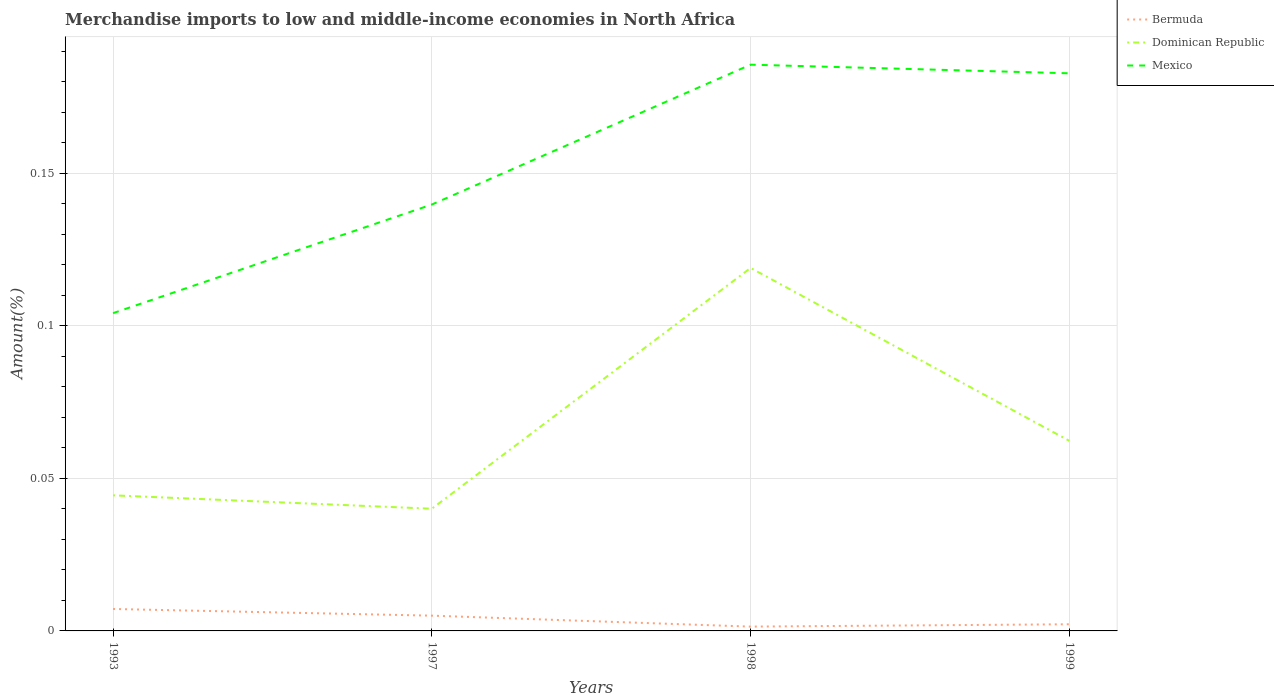How many different coloured lines are there?
Keep it short and to the point. 3. Does the line corresponding to Mexico intersect with the line corresponding to Bermuda?
Offer a very short reply. No. Across all years, what is the maximum percentage of amount earned from merchandise imports in Dominican Republic?
Ensure brevity in your answer.  0.04. What is the total percentage of amount earned from merchandise imports in Mexico in the graph?
Ensure brevity in your answer.  -0.08. What is the difference between the highest and the second highest percentage of amount earned from merchandise imports in Dominican Republic?
Your answer should be compact. 0.08. What is the difference between the highest and the lowest percentage of amount earned from merchandise imports in Bermuda?
Make the answer very short. 2. Is the percentage of amount earned from merchandise imports in Mexico strictly greater than the percentage of amount earned from merchandise imports in Bermuda over the years?
Offer a very short reply. No. How many years are there in the graph?
Provide a short and direct response. 4. Does the graph contain any zero values?
Provide a succinct answer. No. Where does the legend appear in the graph?
Provide a succinct answer. Top right. What is the title of the graph?
Ensure brevity in your answer.  Merchandise imports to low and middle-income economies in North Africa. Does "Turkmenistan" appear as one of the legend labels in the graph?
Offer a terse response. No. What is the label or title of the X-axis?
Give a very brief answer. Years. What is the label or title of the Y-axis?
Provide a short and direct response. Amount(%). What is the Amount(%) of Bermuda in 1993?
Your answer should be very brief. 0.01. What is the Amount(%) of Dominican Republic in 1993?
Your answer should be compact. 0.04. What is the Amount(%) of Mexico in 1993?
Ensure brevity in your answer.  0.1. What is the Amount(%) in Bermuda in 1997?
Your response must be concise. 0.01. What is the Amount(%) in Dominican Republic in 1997?
Offer a very short reply. 0.04. What is the Amount(%) in Mexico in 1997?
Ensure brevity in your answer.  0.14. What is the Amount(%) of Bermuda in 1998?
Your response must be concise. 0. What is the Amount(%) in Dominican Republic in 1998?
Offer a terse response. 0.12. What is the Amount(%) of Mexico in 1998?
Keep it short and to the point. 0.19. What is the Amount(%) of Bermuda in 1999?
Your response must be concise. 0. What is the Amount(%) of Dominican Republic in 1999?
Offer a very short reply. 0.06. What is the Amount(%) in Mexico in 1999?
Your answer should be very brief. 0.18. Across all years, what is the maximum Amount(%) of Bermuda?
Make the answer very short. 0.01. Across all years, what is the maximum Amount(%) of Dominican Republic?
Your response must be concise. 0.12. Across all years, what is the maximum Amount(%) in Mexico?
Keep it short and to the point. 0.19. Across all years, what is the minimum Amount(%) of Bermuda?
Keep it short and to the point. 0. Across all years, what is the minimum Amount(%) in Dominican Republic?
Provide a short and direct response. 0.04. Across all years, what is the minimum Amount(%) of Mexico?
Make the answer very short. 0.1. What is the total Amount(%) of Bermuda in the graph?
Offer a very short reply. 0.02. What is the total Amount(%) in Dominican Republic in the graph?
Give a very brief answer. 0.27. What is the total Amount(%) in Mexico in the graph?
Keep it short and to the point. 0.61. What is the difference between the Amount(%) of Bermuda in 1993 and that in 1997?
Your answer should be very brief. 0. What is the difference between the Amount(%) in Dominican Republic in 1993 and that in 1997?
Your answer should be compact. 0. What is the difference between the Amount(%) of Mexico in 1993 and that in 1997?
Keep it short and to the point. -0.04. What is the difference between the Amount(%) in Bermuda in 1993 and that in 1998?
Offer a very short reply. 0.01. What is the difference between the Amount(%) of Dominican Republic in 1993 and that in 1998?
Ensure brevity in your answer.  -0.07. What is the difference between the Amount(%) in Mexico in 1993 and that in 1998?
Give a very brief answer. -0.08. What is the difference between the Amount(%) of Bermuda in 1993 and that in 1999?
Make the answer very short. 0.01. What is the difference between the Amount(%) of Dominican Republic in 1993 and that in 1999?
Ensure brevity in your answer.  -0.02. What is the difference between the Amount(%) of Mexico in 1993 and that in 1999?
Your answer should be very brief. -0.08. What is the difference between the Amount(%) in Bermuda in 1997 and that in 1998?
Offer a very short reply. 0. What is the difference between the Amount(%) in Dominican Republic in 1997 and that in 1998?
Offer a very short reply. -0.08. What is the difference between the Amount(%) of Mexico in 1997 and that in 1998?
Your answer should be very brief. -0.05. What is the difference between the Amount(%) of Bermuda in 1997 and that in 1999?
Ensure brevity in your answer.  0. What is the difference between the Amount(%) in Dominican Republic in 1997 and that in 1999?
Offer a terse response. -0.02. What is the difference between the Amount(%) of Mexico in 1997 and that in 1999?
Offer a terse response. -0.04. What is the difference between the Amount(%) of Bermuda in 1998 and that in 1999?
Your response must be concise. -0. What is the difference between the Amount(%) in Dominican Republic in 1998 and that in 1999?
Provide a succinct answer. 0.06. What is the difference between the Amount(%) in Mexico in 1998 and that in 1999?
Your answer should be very brief. 0. What is the difference between the Amount(%) in Bermuda in 1993 and the Amount(%) in Dominican Republic in 1997?
Keep it short and to the point. -0.03. What is the difference between the Amount(%) of Bermuda in 1993 and the Amount(%) of Mexico in 1997?
Make the answer very short. -0.13. What is the difference between the Amount(%) in Dominican Republic in 1993 and the Amount(%) in Mexico in 1997?
Ensure brevity in your answer.  -0.1. What is the difference between the Amount(%) of Bermuda in 1993 and the Amount(%) of Dominican Republic in 1998?
Provide a short and direct response. -0.11. What is the difference between the Amount(%) of Bermuda in 1993 and the Amount(%) of Mexico in 1998?
Your response must be concise. -0.18. What is the difference between the Amount(%) in Dominican Republic in 1993 and the Amount(%) in Mexico in 1998?
Make the answer very short. -0.14. What is the difference between the Amount(%) in Bermuda in 1993 and the Amount(%) in Dominican Republic in 1999?
Provide a succinct answer. -0.06. What is the difference between the Amount(%) of Bermuda in 1993 and the Amount(%) of Mexico in 1999?
Your answer should be compact. -0.18. What is the difference between the Amount(%) of Dominican Republic in 1993 and the Amount(%) of Mexico in 1999?
Offer a very short reply. -0.14. What is the difference between the Amount(%) in Bermuda in 1997 and the Amount(%) in Dominican Republic in 1998?
Make the answer very short. -0.11. What is the difference between the Amount(%) of Bermuda in 1997 and the Amount(%) of Mexico in 1998?
Ensure brevity in your answer.  -0.18. What is the difference between the Amount(%) of Dominican Republic in 1997 and the Amount(%) of Mexico in 1998?
Your answer should be compact. -0.15. What is the difference between the Amount(%) in Bermuda in 1997 and the Amount(%) in Dominican Republic in 1999?
Provide a succinct answer. -0.06. What is the difference between the Amount(%) in Bermuda in 1997 and the Amount(%) in Mexico in 1999?
Ensure brevity in your answer.  -0.18. What is the difference between the Amount(%) in Dominican Republic in 1997 and the Amount(%) in Mexico in 1999?
Your answer should be very brief. -0.14. What is the difference between the Amount(%) of Bermuda in 1998 and the Amount(%) of Dominican Republic in 1999?
Your response must be concise. -0.06. What is the difference between the Amount(%) in Bermuda in 1998 and the Amount(%) in Mexico in 1999?
Provide a short and direct response. -0.18. What is the difference between the Amount(%) in Dominican Republic in 1998 and the Amount(%) in Mexico in 1999?
Offer a very short reply. -0.06. What is the average Amount(%) in Bermuda per year?
Make the answer very short. 0. What is the average Amount(%) in Dominican Republic per year?
Your answer should be very brief. 0.07. What is the average Amount(%) in Mexico per year?
Your answer should be compact. 0.15. In the year 1993, what is the difference between the Amount(%) in Bermuda and Amount(%) in Dominican Republic?
Your answer should be very brief. -0.04. In the year 1993, what is the difference between the Amount(%) of Bermuda and Amount(%) of Mexico?
Your answer should be compact. -0.1. In the year 1993, what is the difference between the Amount(%) in Dominican Republic and Amount(%) in Mexico?
Offer a terse response. -0.06. In the year 1997, what is the difference between the Amount(%) of Bermuda and Amount(%) of Dominican Republic?
Your answer should be very brief. -0.04. In the year 1997, what is the difference between the Amount(%) of Bermuda and Amount(%) of Mexico?
Your answer should be very brief. -0.13. In the year 1997, what is the difference between the Amount(%) in Dominican Republic and Amount(%) in Mexico?
Keep it short and to the point. -0.1. In the year 1998, what is the difference between the Amount(%) of Bermuda and Amount(%) of Dominican Republic?
Keep it short and to the point. -0.12. In the year 1998, what is the difference between the Amount(%) in Bermuda and Amount(%) in Mexico?
Your answer should be very brief. -0.18. In the year 1998, what is the difference between the Amount(%) in Dominican Republic and Amount(%) in Mexico?
Your answer should be compact. -0.07. In the year 1999, what is the difference between the Amount(%) of Bermuda and Amount(%) of Dominican Republic?
Give a very brief answer. -0.06. In the year 1999, what is the difference between the Amount(%) in Bermuda and Amount(%) in Mexico?
Your response must be concise. -0.18. In the year 1999, what is the difference between the Amount(%) in Dominican Republic and Amount(%) in Mexico?
Provide a succinct answer. -0.12. What is the ratio of the Amount(%) of Bermuda in 1993 to that in 1997?
Make the answer very short. 1.44. What is the ratio of the Amount(%) of Dominican Republic in 1993 to that in 1997?
Offer a terse response. 1.11. What is the ratio of the Amount(%) in Mexico in 1993 to that in 1997?
Give a very brief answer. 0.75. What is the ratio of the Amount(%) in Bermuda in 1993 to that in 1998?
Offer a very short reply. 5.09. What is the ratio of the Amount(%) of Dominican Republic in 1993 to that in 1998?
Your answer should be compact. 0.37. What is the ratio of the Amount(%) of Mexico in 1993 to that in 1998?
Offer a terse response. 0.56. What is the ratio of the Amount(%) of Bermuda in 1993 to that in 1999?
Offer a terse response. 3.3. What is the ratio of the Amount(%) in Dominican Republic in 1993 to that in 1999?
Ensure brevity in your answer.  0.71. What is the ratio of the Amount(%) in Mexico in 1993 to that in 1999?
Give a very brief answer. 0.57. What is the ratio of the Amount(%) of Bermuda in 1997 to that in 1998?
Provide a succinct answer. 3.54. What is the ratio of the Amount(%) in Dominican Republic in 1997 to that in 1998?
Give a very brief answer. 0.34. What is the ratio of the Amount(%) of Mexico in 1997 to that in 1998?
Your answer should be very brief. 0.75. What is the ratio of the Amount(%) of Bermuda in 1997 to that in 1999?
Give a very brief answer. 2.3. What is the ratio of the Amount(%) of Dominican Republic in 1997 to that in 1999?
Ensure brevity in your answer.  0.64. What is the ratio of the Amount(%) in Mexico in 1997 to that in 1999?
Offer a very short reply. 0.76. What is the ratio of the Amount(%) in Bermuda in 1998 to that in 1999?
Your answer should be very brief. 0.65. What is the ratio of the Amount(%) of Dominican Republic in 1998 to that in 1999?
Your answer should be compact. 1.91. What is the ratio of the Amount(%) of Mexico in 1998 to that in 1999?
Provide a short and direct response. 1.02. What is the difference between the highest and the second highest Amount(%) in Bermuda?
Ensure brevity in your answer.  0. What is the difference between the highest and the second highest Amount(%) in Dominican Republic?
Give a very brief answer. 0.06. What is the difference between the highest and the second highest Amount(%) of Mexico?
Ensure brevity in your answer.  0. What is the difference between the highest and the lowest Amount(%) in Bermuda?
Ensure brevity in your answer.  0.01. What is the difference between the highest and the lowest Amount(%) in Dominican Republic?
Your answer should be very brief. 0.08. What is the difference between the highest and the lowest Amount(%) in Mexico?
Give a very brief answer. 0.08. 